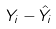Convert formula to latex. <formula><loc_0><loc_0><loc_500><loc_500>Y _ { i } - \hat { Y } _ { i }</formula> 